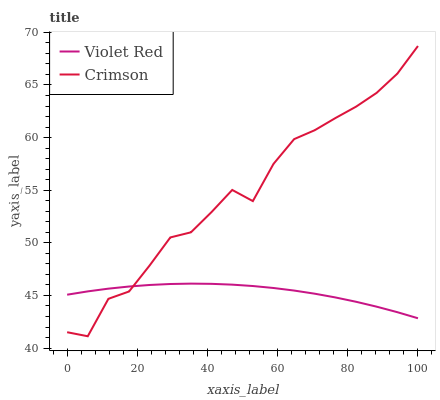Does Violet Red have the minimum area under the curve?
Answer yes or no. Yes. Does Crimson have the maximum area under the curve?
Answer yes or no. Yes. Does Violet Red have the maximum area under the curve?
Answer yes or no. No. Is Violet Red the smoothest?
Answer yes or no. Yes. Is Crimson the roughest?
Answer yes or no. Yes. Is Violet Red the roughest?
Answer yes or no. No. Does Crimson have the lowest value?
Answer yes or no. Yes. Does Violet Red have the lowest value?
Answer yes or no. No. Does Crimson have the highest value?
Answer yes or no. Yes. Does Violet Red have the highest value?
Answer yes or no. No. Does Violet Red intersect Crimson?
Answer yes or no. Yes. Is Violet Red less than Crimson?
Answer yes or no. No. Is Violet Red greater than Crimson?
Answer yes or no. No. 